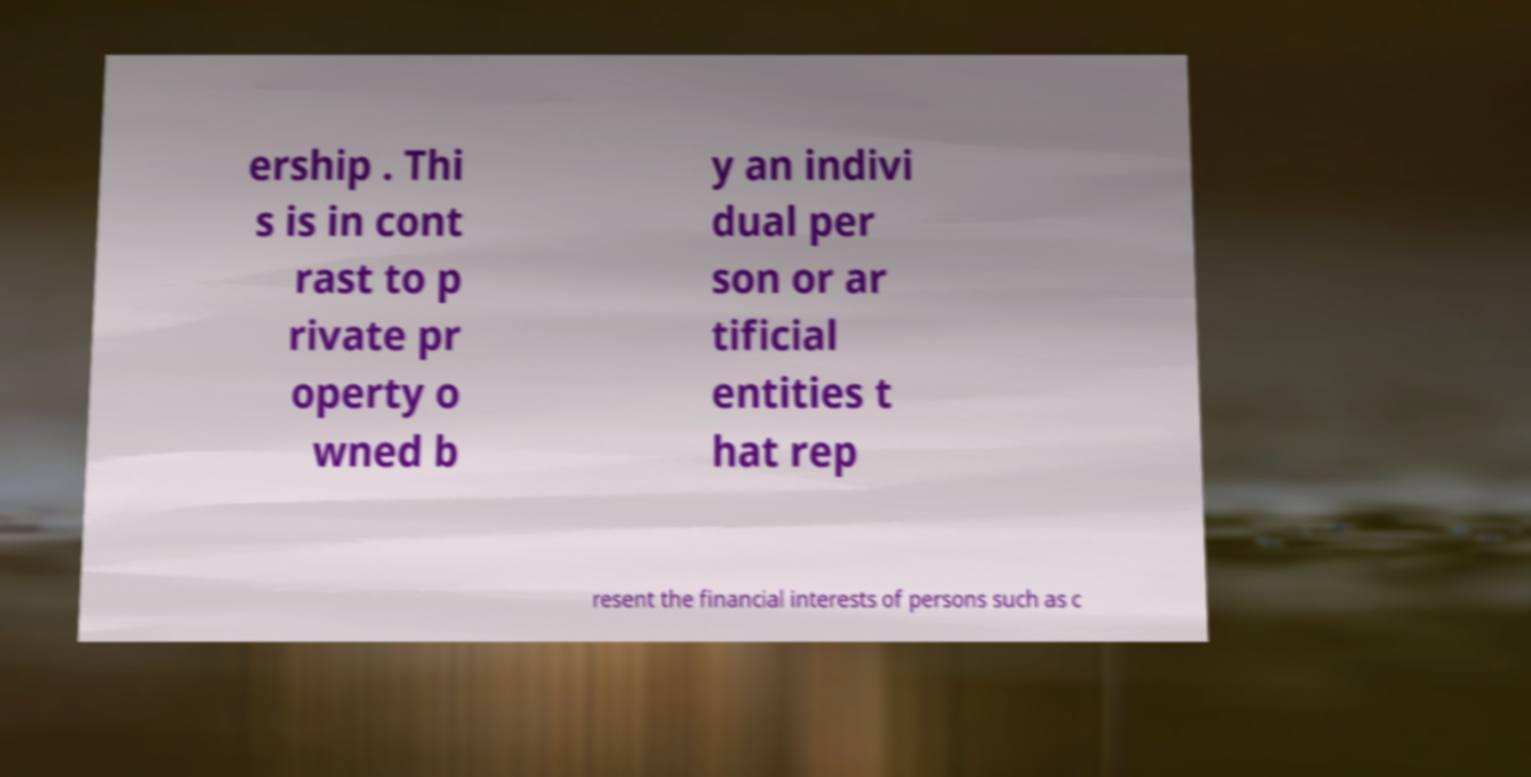Can you accurately transcribe the text from the provided image for me? ership . Thi s is in cont rast to p rivate pr operty o wned b y an indivi dual per son or ar tificial entities t hat rep resent the financial interests of persons such as c 